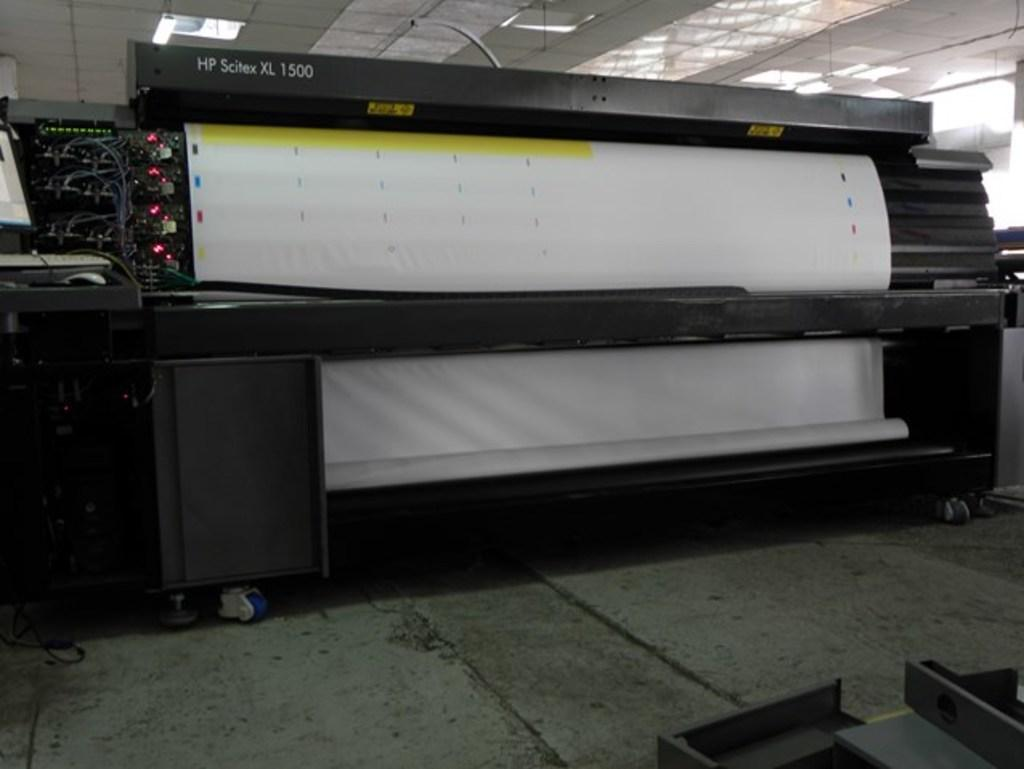What type of equipment is in the image? There is a machine, a device, and a computer in the image. What are the computer accessories visible in the image? A keyboard and a mouse are present in the image. Where are the computer, keyboard, and mouse located? They are on a table in the image. What can be seen at the top of the image? There are lights at the top of the image. What is visible at the bottom of the image? There is a floor visible at the bottom of the image. What time of day is it in the image, and who is talking to the system? The time of day cannot be determined from the image, and there is no person present to talk to the system. 